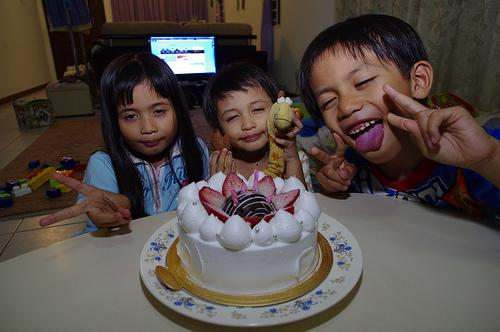Provide a brief description of the main elements in the image. Three children are sitting in front of a white birthday cake, holding toys and making peace signs, with a turned on TV and toys on the floor. Describe the scene in the image, paying attention to the background. In a room with a turned-on TV and toys scattered on a brown rug over a tiled floor, three kids sit together, playing with toys and showing peace signs. Focus on the children's appearance and actions in the photograph. Three kids, one with eyes closed and tongue out, one in a blue shirt, and one holding a toy giraffe, sit in front of a cake, making peace signs. Create a narrative-style description of the activities happening in the photograph. The children gather around, excited for the birthday celebrations, as they play with toys and make peace signs, while the TV flickers in the background. Give a simple and concise summary of the picture's content. Children pose with peace signs, surrounded by toys and a white birthday cake topped with flowers and strawberries. Write a short summary about the children and their actions, focusing on individual details. One child holds a toy giraffe, another displays a peace sign in a blue shirt, and the third has their eyes closed and tongue out, all with birthday cake as the focal point. Mention the primary object in the picture along with any noteworthy details. A white cake, adorned with blue flowers and sliced strawberries, is on a white round floral plate, with a candle and cut strawberry on top. Paint a vivid description of the centerpiece in the image. The delectable white cake, adorned with intricate blue icing flowers and luscious sliced strawberries, beckons the excited children to indulge in its sweetness. List the main elements of the picture in a concise manner. White birthday cake with flowers and strawberries, three children with toys and peace signs, turned on TV, floor with toys. Describe the objects found in the setting of the image. The setting includes a television turned on, multicolored children's toys, a brown rug over large tiled flooring, and a white cake on a floral plate. 